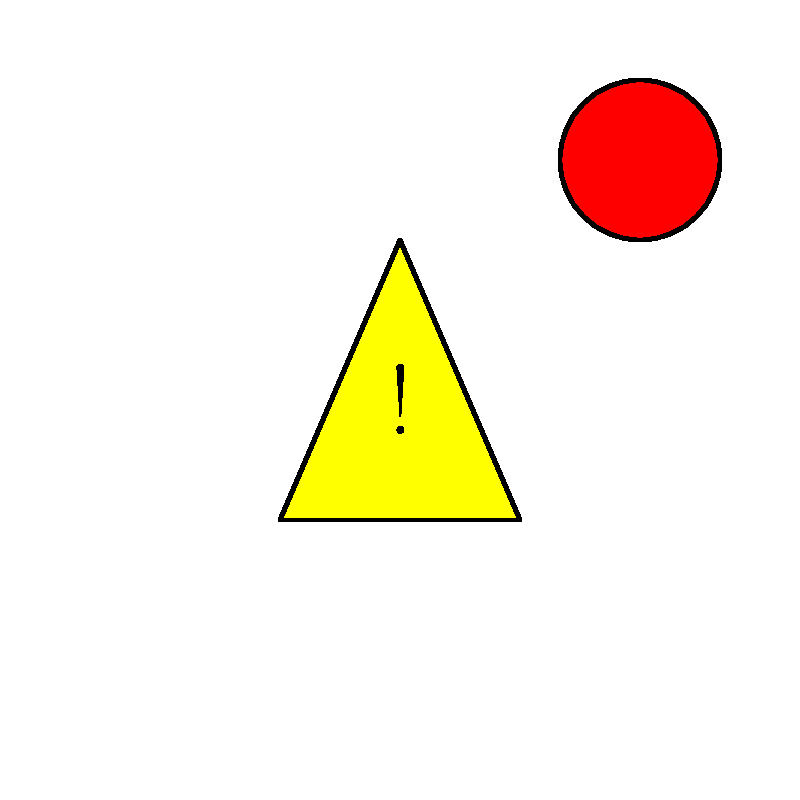In the given emergency alert system diagram, which symbol should you prioritize if all three were to appear simultaneously, and what immediate action should you take? To answer this question, we need to analyze the three symbols presented in the emergency alert system diagram and understand their meanings and priorities:

1. Yellow Triangle with "!": This is a warning symbol, indicating a potential hazard or danger.
2. Red Circle with "S": This symbol represents "Stop," signaling an immediate halt to operations or activities.
3. Green Square with "E": This symbol indicates "Evacuation," suggesting the need to leave the area.

When prioritizing these symbols, we should consider the following factors:

1. Immediate threat to life and safety
2. Urgency of the required action
3. Potential consequences of delay

Given these considerations:

1. The "Stop" signal (red circle) requires immediate action but doesn't necessarily indicate a life-threatening situation.
2. The "Warning" symbol (yellow triangle) alerts to potential danger but doesn't specify an immediate action.
3. The "Evacuation" signal (green square) implies an immediate threat to safety that requires prompt action to preserve life.

Therefore, the evacuation signal should be prioritized as it indicates the most urgent need to protect lives by leaving the area. The immediate action to take would be to initiate and oversee the evacuation procedures according to established security protocols.
Answer: Prioritize the green square (Evacuation); immediately initiate evacuation procedures. 